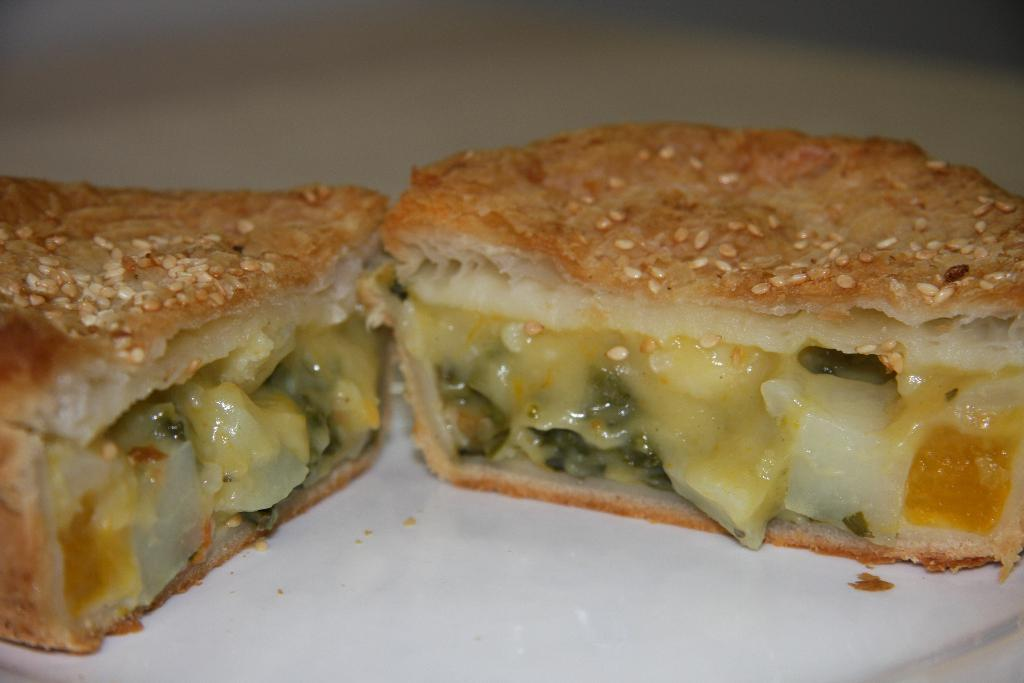What type of food is visible in the image? There is a veg sandwich slice in the image. Where is the veg sandwich slice located? The veg sandwich slice is on a table. What advice does the mother give to the tramp in the image? There is no mother or tramp present in the image; it only features a veg sandwich slice on a table. 